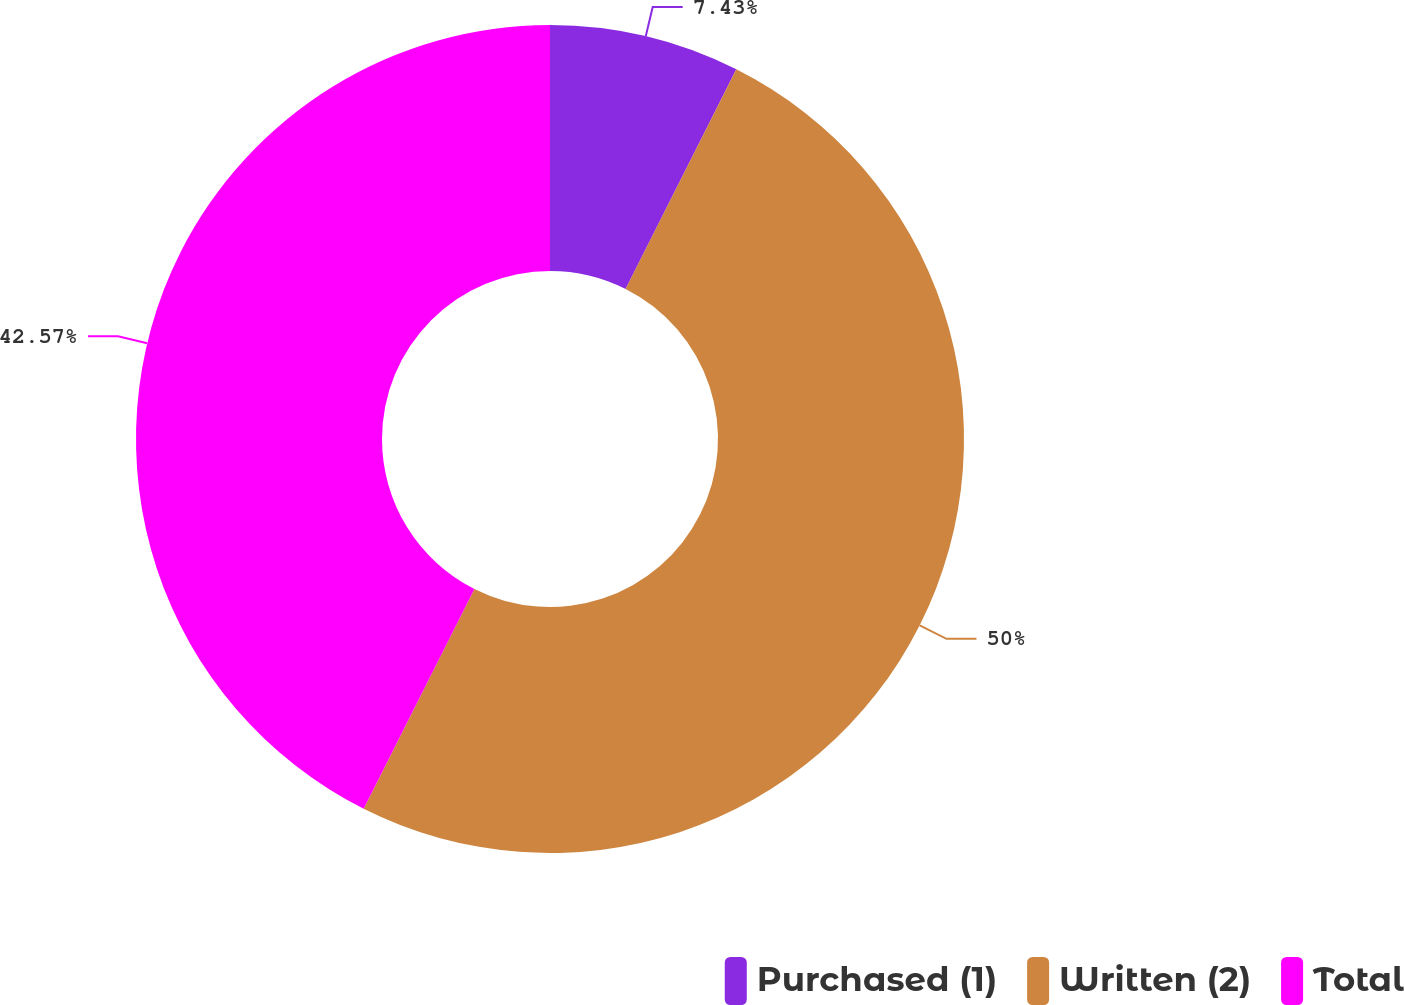<chart> <loc_0><loc_0><loc_500><loc_500><pie_chart><fcel>Purchased (1)<fcel>Written (2)<fcel>Total<nl><fcel>7.43%<fcel>50.0%<fcel>42.57%<nl></chart> 